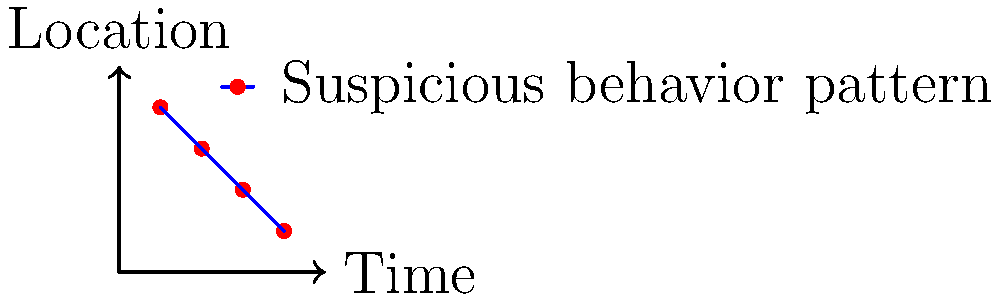Based on the surveillance camera footage snapshots represented in the graph, which of the following best describes the suspicious behavior pattern observed?

A) Random movement
B) Circular pattern
C) Linear progression
D) Stationary activity To identify the suspicious behavior pattern from the surveillance camera footage snapshots, let's analyze the graph step-by-step:

1. The x-axis represents time, while the y-axis represents location.

2. The red dots on the graph indicate specific points where suspicious activity was observed.

3. The blue line connecting these points shows the progression of the suspicious behavior over time.

4. Observing the pattern:
   a) The points start from the top-left corner (0.2, 0.8) and move towards the bottom-right corner (0.8, 0.2).
   b) This movement indicates a consistent progression from one location to another over time.
   c) The line connecting the points is relatively straight, suggesting a direct and purposeful movement.

5. Analyzing the options:
   A) Random movement: This would show scattered points without a clear pattern.
   B) Circular pattern: This would show points forming a loop or circle.
   C) Linear progression: This matches our observation of a consistent, direct movement across time and location.
   D) Stationary activity: This would show points clustered in one area without significant movement.

6. Based on the analysis, the pattern most closely resembles a linear progression, as it shows a direct and consistent movement from one point to another over time.

Therefore, the suspicious behavior pattern observed in the surveillance camera footage snapshots is best described as a linear progression.
Answer: Linear progression 